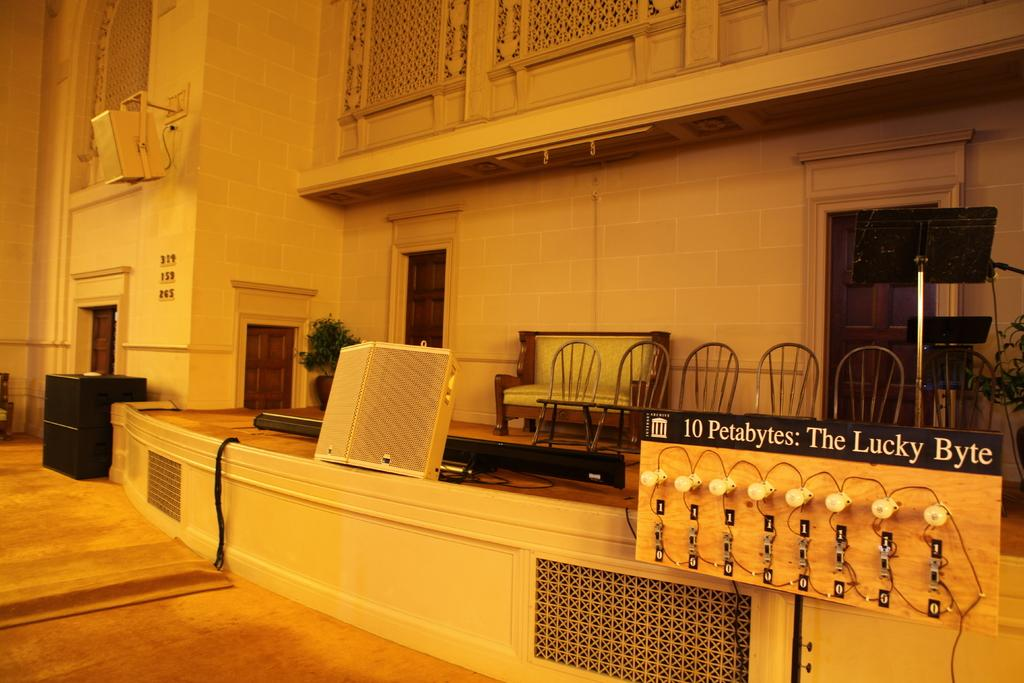What can be seen in the foreground area of the image? There are objects in the foreground area of the image. What is visible in the background of the image? There are doors, a building structure, a sofa, and chairs in the background of the image. Where is the basketball court located in the image? There is no basketball court present in the image. What type of farm animals can be seen grazing in the background of the image? There are no farm animals present in the image. 